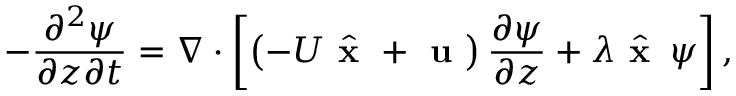Convert formula to latex. <formula><loc_0><loc_0><loc_500><loc_500>- \frac { \partial ^ { 2 } \psi } { \partial z \partial t } = \nabla \cdot \left [ \left ( - U \hat { x } + u \right ) \frac { \partial \psi } { \partial z } + \lambda \hat { x } \, \psi \right ] ,</formula> 